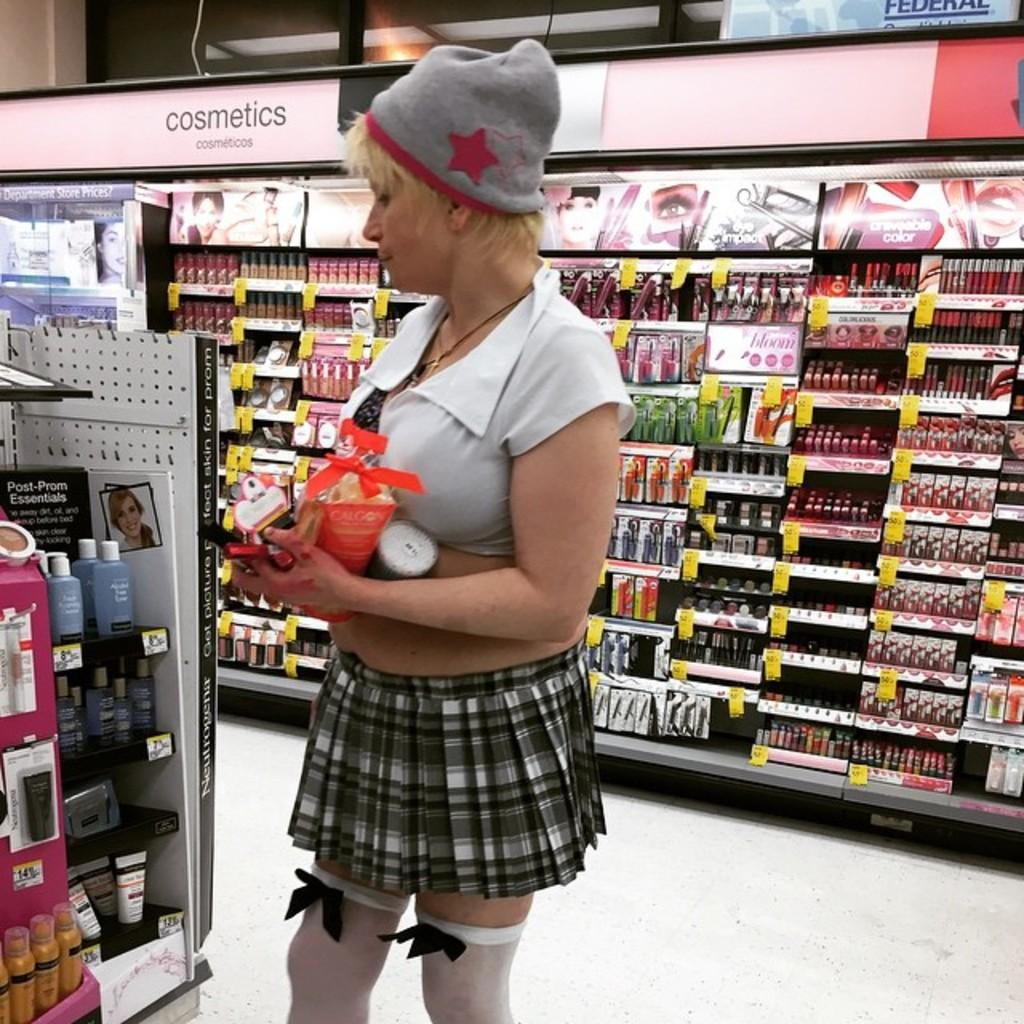Provide a one-sentence caption for the provided image. A blonde woman wearing a school girl costume by the cosmetics section of a store. 